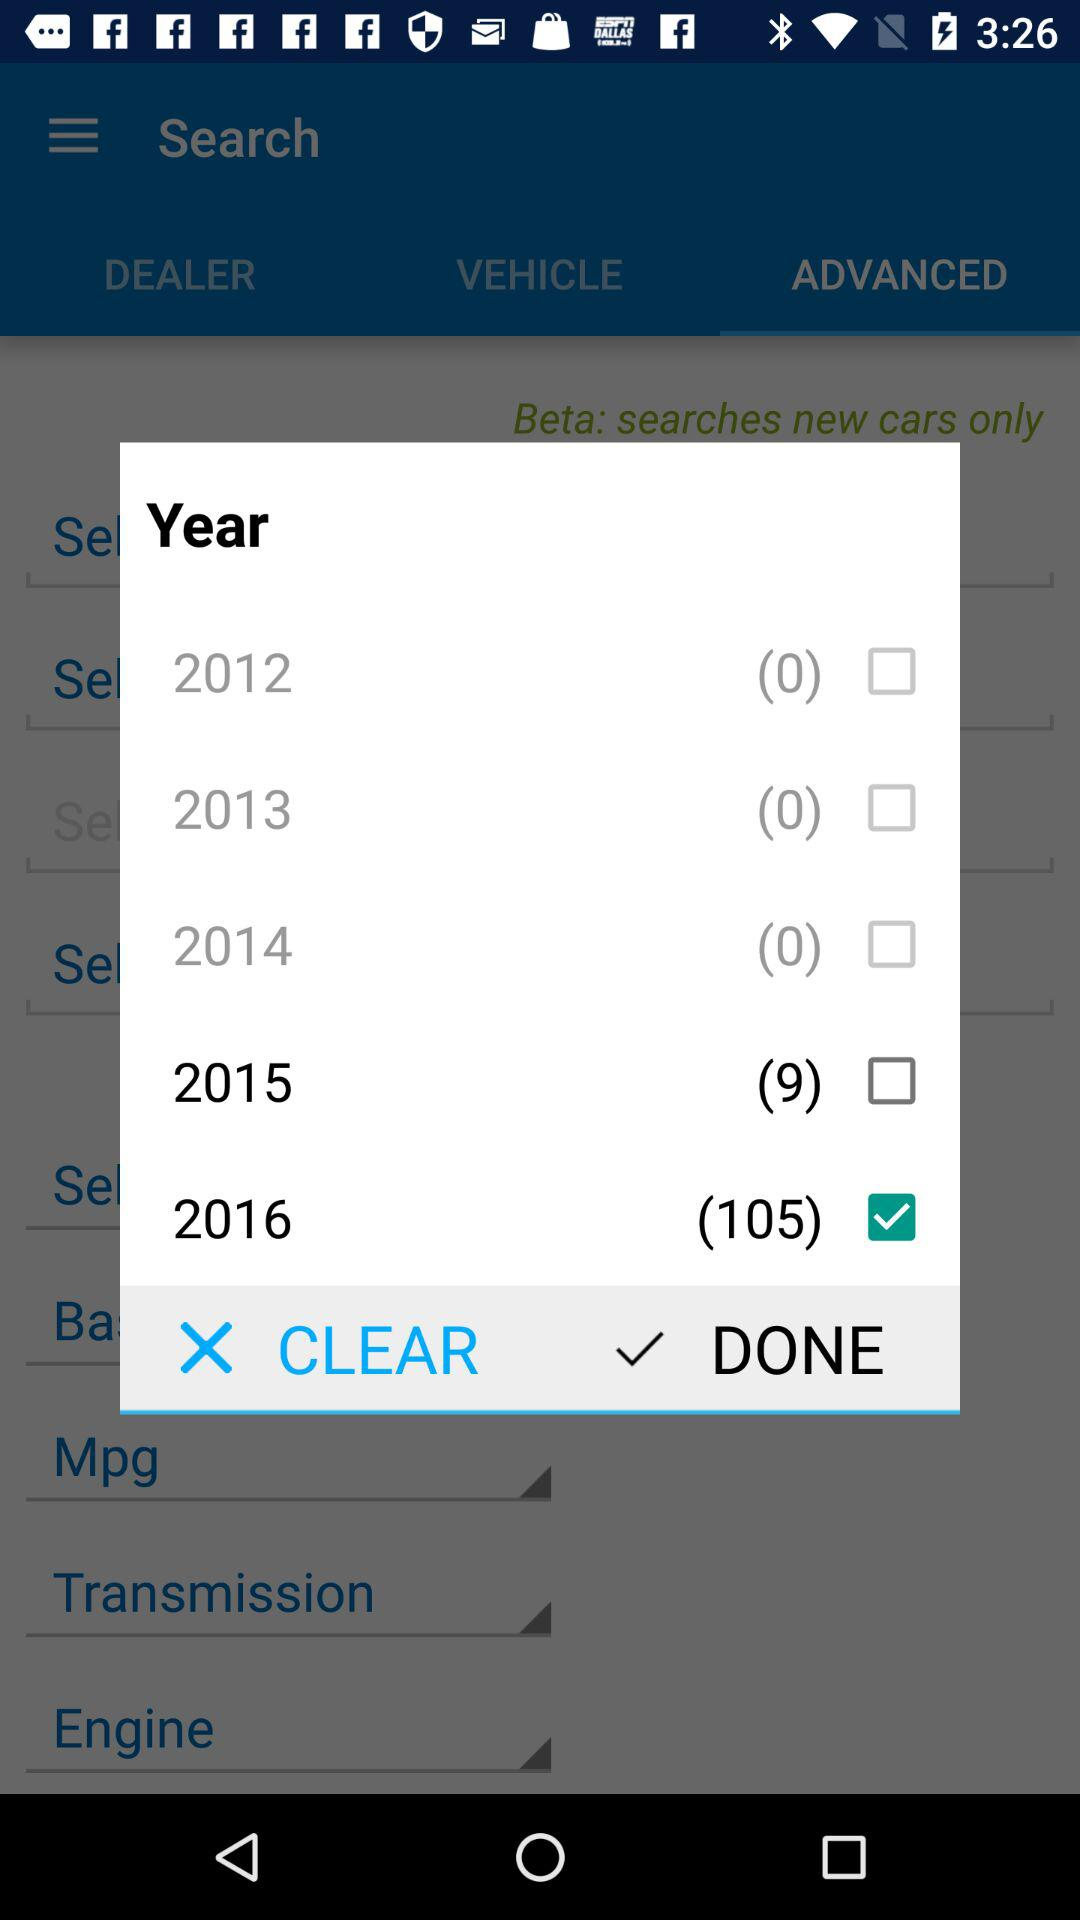What is the total number shown for 2016? The total number shown for 2016 is 105. 